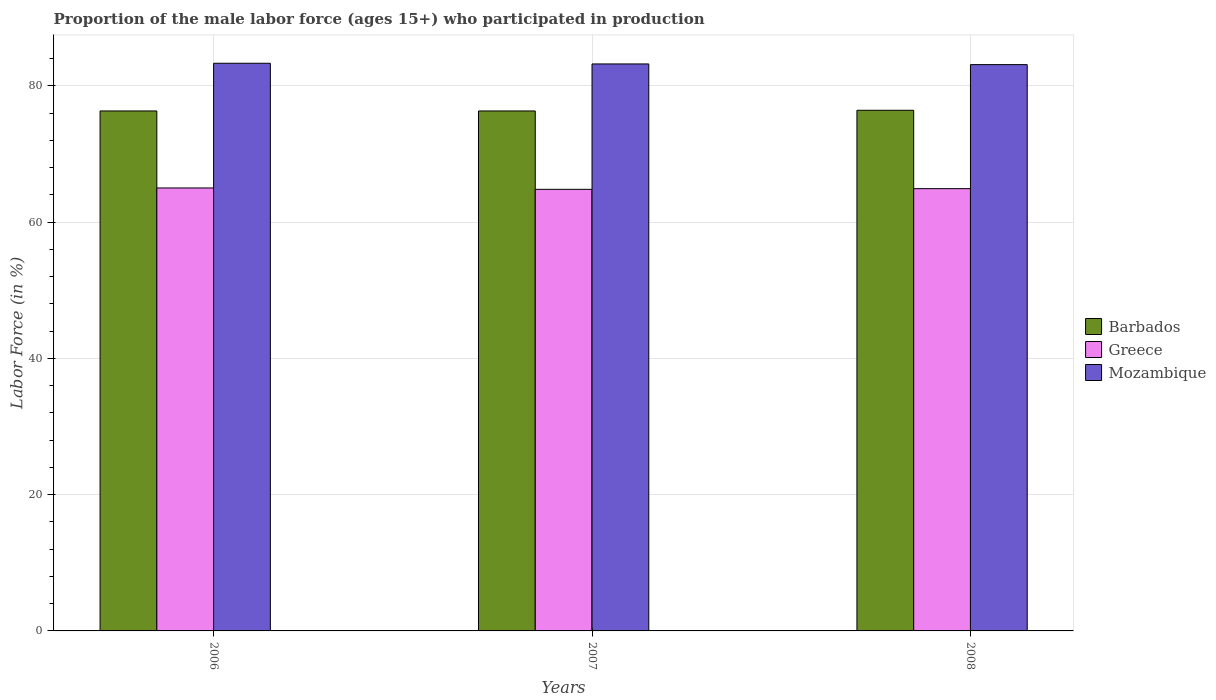How many different coloured bars are there?
Provide a short and direct response. 3. Are the number of bars per tick equal to the number of legend labels?
Keep it short and to the point. Yes. How many bars are there on the 1st tick from the left?
Make the answer very short. 3. How many bars are there on the 1st tick from the right?
Provide a succinct answer. 3. What is the label of the 3rd group of bars from the left?
Your answer should be very brief. 2008. What is the proportion of the male labor force who participated in production in Mozambique in 2006?
Your answer should be compact. 83.3. Across all years, what is the maximum proportion of the male labor force who participated in production in Greece?
Provide a succinct answer. 65. Across all years, what is the minimum proportion of the male labor force who participated in production in Barbados?
Keep it short and to the point. 76.3. In which year was the proportion of the male labor force who participated in production in Barbados minimum?
Provide a short and direct response. 2006. What is the total proportion of the male labor force who participated in production in Greece in the graph?
Give a very brief answer. 194.7. What is the difference between the proportion of the male labor force who participated in production in Greece in 2006 and that in 2007?
Make the answer very short. 0.2. What is the difference between the proportion of the male labor force who participated in production in Barbados in 2008 and the proportion of the male labor force who participated in production in Mozambique in 2006?
Give a very brief answer. -6.9. What is the average proportion of the male labor force who participated in production in Barbados per year?
Offer a terse response. 76.33. In the year 2007, what is the difference between the proportion of the male labor force who participated in production in Mozambique and proportion of the male labor force who participated in production in Greece?
Provide a succinct answer. 18.4. What is the ratio of the proportion of the male labor force who participated in production in Barbados in 2006 to that in 2008?
Your answer should be compact. 1. Is the proportion of the male labor force who participated in production in Mozambique in 2007 less than that in 2008?
Offer a terse response. No. What is the difference between the highest and the second highest proportion of the male labor force who participated in production in Barbados?
Give a very brief answer. 0.1. What is the difference between the highest and the lowest proportion of the male labor force who participated in production in Barbados?
Ensure brevity in your answer.  0.1. What does the 2nd bar from the left in 2008 represents?
Provide a short and direct response. Greece. How many bars are there?
Ensure brevity in your answer.  9. Are all the bars in the graph horizontal?
Your response must be concise. No. How many years are there in the graph?
Provide a succinct answer. 3. Does the graph contain any zero values?
Ensure brevity in your answer.  No. Does the graph contain grids?
Make the answer very short. Yes. How are the legend labels stacked?
Your answer should be very brief. Vertical. What is the title of the graph?
Offer a terse response. Proportion of the male labor force (ages 15+) who participated in production. Does "Sub-Saharan Africa (developing only)" appear as one of the legend labels in the graph?
Give a very brief answer. No. What is the label or title of the X-axis?
Give a very brief answer. Years. What is the label or title of the Y-axis?
Provide a succinct answer. Labor Force (in %). What is the Labor Force (in %) of Barbados in 2006?
Ensure brevity in your answer.  76.3. What is the Labor Force (in %) of Mozambique in 2006?
Your answer should be very brief. 83.3. What is the Labor Force (in %) in Barbados in 2007?
Keep it short and to the point. 76.3. What is the Labor Force (in %) in Greece in 2007?
Offer a very short reply. 64.8. What is the Labor Force (in %) of Mozambique in 2007?
Provide a short and direct response. 83.2. What is the Labor Force (in %) of Barbados in 2008?
Your response must be concise. 76.4. What is the Labor Force (in %) of Greece in 2008?
Your response must be concise. 64.9. What is the Labor Force (in %) of Mozambique in 2008?
Offer a very short reply. 83.1. Across all years, what is the maximum Labor Force (in %) of Barbados?
Keep it short and to the point. 76.4. Across all years, what is the maximum Labor Force (in %) in Greece?
Your answer should be very brief. 65. Across all years, what is the maximum Labor Force (in %) in Mozambique?
Your answer should be compact. 83.3. Across all years, what is the minimum Labor Force (in %) in Barbados?
Offer a terse response. 76.3. Across all years, what is the minimum Labor Force (in %) in Greece?
Offer a very short reply. 64.8. Across all years, what is the minimum Labor Force (in %) in Mozambique?
Your response must be concise. 83.1. What is the total Labor Force (in %) in Barbados in the graph?
Your response must be concise. 229. What is the total Labor Force (in %) of Greece in the graph?
Offer a very short reply. 194.7. What is the total Labor Force (in %) of Mozambique in the graph?
Provide a short and direct response. 249.6. What is the difference between the Labor Force (in %) in Barbados in 2006 and that in 2007?
Your answer should be very brief. 0. What is the difference between the Labor Force (in %) of Greece in 2006 and that in 2007?
Keep it short and to the point. 0.2. What is the difference between the Labor Force (in %) in Mozambique in 2006 and that in 2008?
Your answer should be very brief. 0.2. What is the difference between the Labor Force (in %) of Barbados in 2007 and that in 2008?
Make the answer very short. -0.1. What is the difference between the Labor Force (in %) of Greece in 2007 and that in 2008?
Keep it short and to the point. -0.1. What is the difference between the Labor Force (in %) in Mozambique in 2007 and that in 2008?
Offer a very short reply. 0.1. What is the difference between the Labor Force (in %) of Barbados in 2006 and the Labor Force (in %) of Greece in 2007?
Offer a very short reply. 11.5. What is the difference between the Labor Force (in %) in Barbados in 2006 and the Labor Force (in %) in Mozambique in 2007?
Provide a short and direct response. -6.9. What is the difference between the Labor Force (in %) of Greece in 2006 and the Labor Force (in %) of Mozambique in 2007?
Provide a short and direct response. -18.2. What is the difference between the Labor Force (in %) of Barbados in 2006 and the Labor Force (in %) of Greece in 2008?
Offer a terse response. 11.4. What is the difference between the Labor Force (in %) in Greece in 2006 and the Labor Force (in %) in Mozambique in 2008?
Provide a succinct answer. -18.1. What is the difference between the Labor Force (in %) of Barbados in 2007 and the Labor Force (in %) of Greece in 2008?
Your answer should be compact. 11.4. What is the difference between the Labor Force (in %) in Barbados in 2007 and the Labor Force (in %) in Mozambique in 2008?
Your response must be concise. -6.8. What is the difference between the Labor Force (in %) of Greece in 2007 and the Labor Force (in %) of Mozambique in 2008?
Ensure brevity in your answer.  -18.3. What is the average Labor Force (in %) of Barbados per year?
Your answer should be compact. 76.33. What is the average Labor Force (in %) in Greece per year?
Your answer should be very brief. 64.9. What is the average Labor Force (in %) in Mozambique per year?
Keep it short and to the point. 83.2. In the year 2006, what is the difference between the Labor Force (in %) in Greece and Labor Force (in %) in Mozambique?
Your response must be concise. -18.3. In the year 2007, what is the difference between the Labor Force (in %) in Barbados and Labor Force (in %) in Mozambique?
Offer a very short reply. -6.9. In the year 2007, what is the difference between the Labor Force (in %) in Greece and Labor Force (in %) in Mozambique?
Give a very brief answer. -18.4. In the year 2008, what is the difference between the Labor Force (in %) in Barbados and Labor Force (in %) in Mozambique?
Your answer should be very brief. -6.7. In the year 2008, what is the difference between the Labor Force (in %) of Greece and Labor Force (in %) of Mozambique?
Keep it short and to the point. -18.2. What is the ratio of the Labor Force (in %) in Barbados in 2006 to that in 2007?
Provide a short and direct response. 1. What is the ratio of the Labor Force (in %) in Greece in 2006 to that in 2007?
Offer a very short reply. 1. What is the ratio of the Labor Force (in %) in Barbados in 2007 to that in 2008?
Provide a succinct answer. 1. What is the ratio of the Labor Force (in %) of Greece in 2007 to that in 2008?
Keep it short and to the point. 1. What is the ratio of the Labor Force (in %) in Mozambique in 2007 to that in 2008?
Your response must be concise. 1. What is the difference between the highest and the second highest Labor Force (in %) in Greece?
Your answer should be compact. 0.1. What is the difference between the highest and the lowest Labor Force (in %) in Barbados?
Provide a succinct answer. 0.1. What is the difference between the highest and the lowest Labor Force (in %) in Greece?
Make the answer very short. 0.2. 